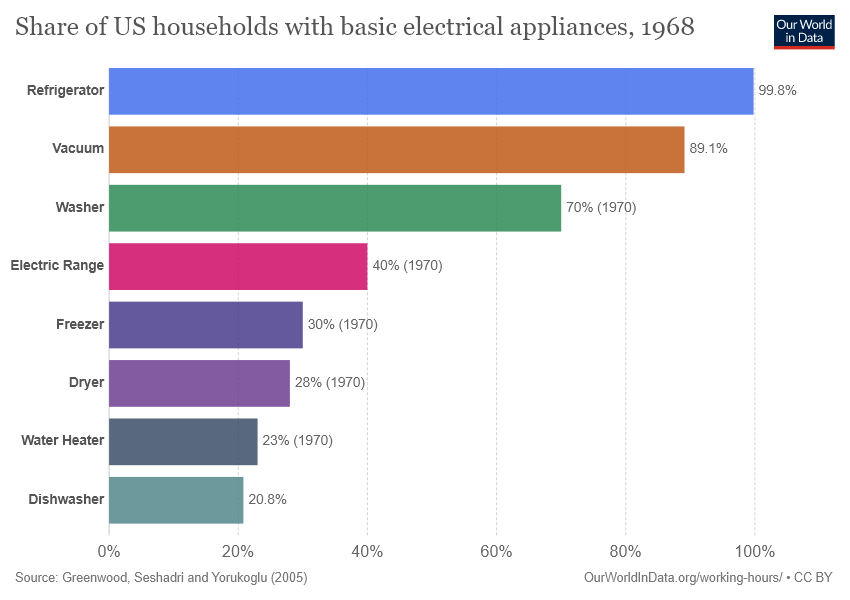Point out several critical features in this image. Eight colors are represented in the bar. The largest and smallest bars differ by 79 units. 